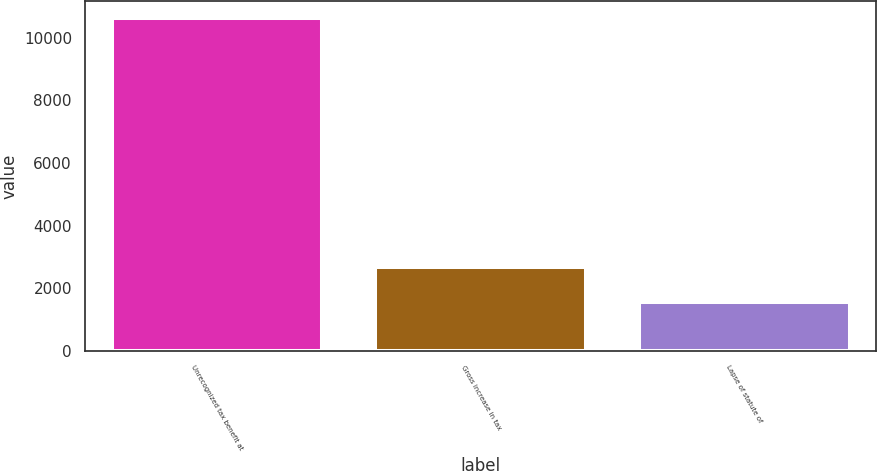Convert chart to OTSL. <chart><loc_0><loc_0><loc_500><loc_500><bar_chart><fcel>Unrecognized tax benefit at<fcel>Gross increase in tax<fcel>Lapse of statute of<nl><fcel>10637<fcel>2679<fcel>1566<nl></chart> 